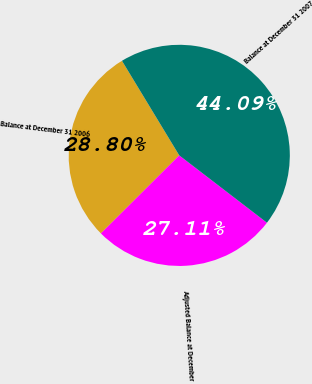Convert chart. <chart><loc_0><loc_0><loc_500><loc_500><pie_chart><fcel>Balance at December 31 2006<fcel>Adjusted Balance at December<fcel>Balance at December 31 2007<nl><fcel>28.8%<fcel>27.11%<fcel>44.09%<nl></chart> 